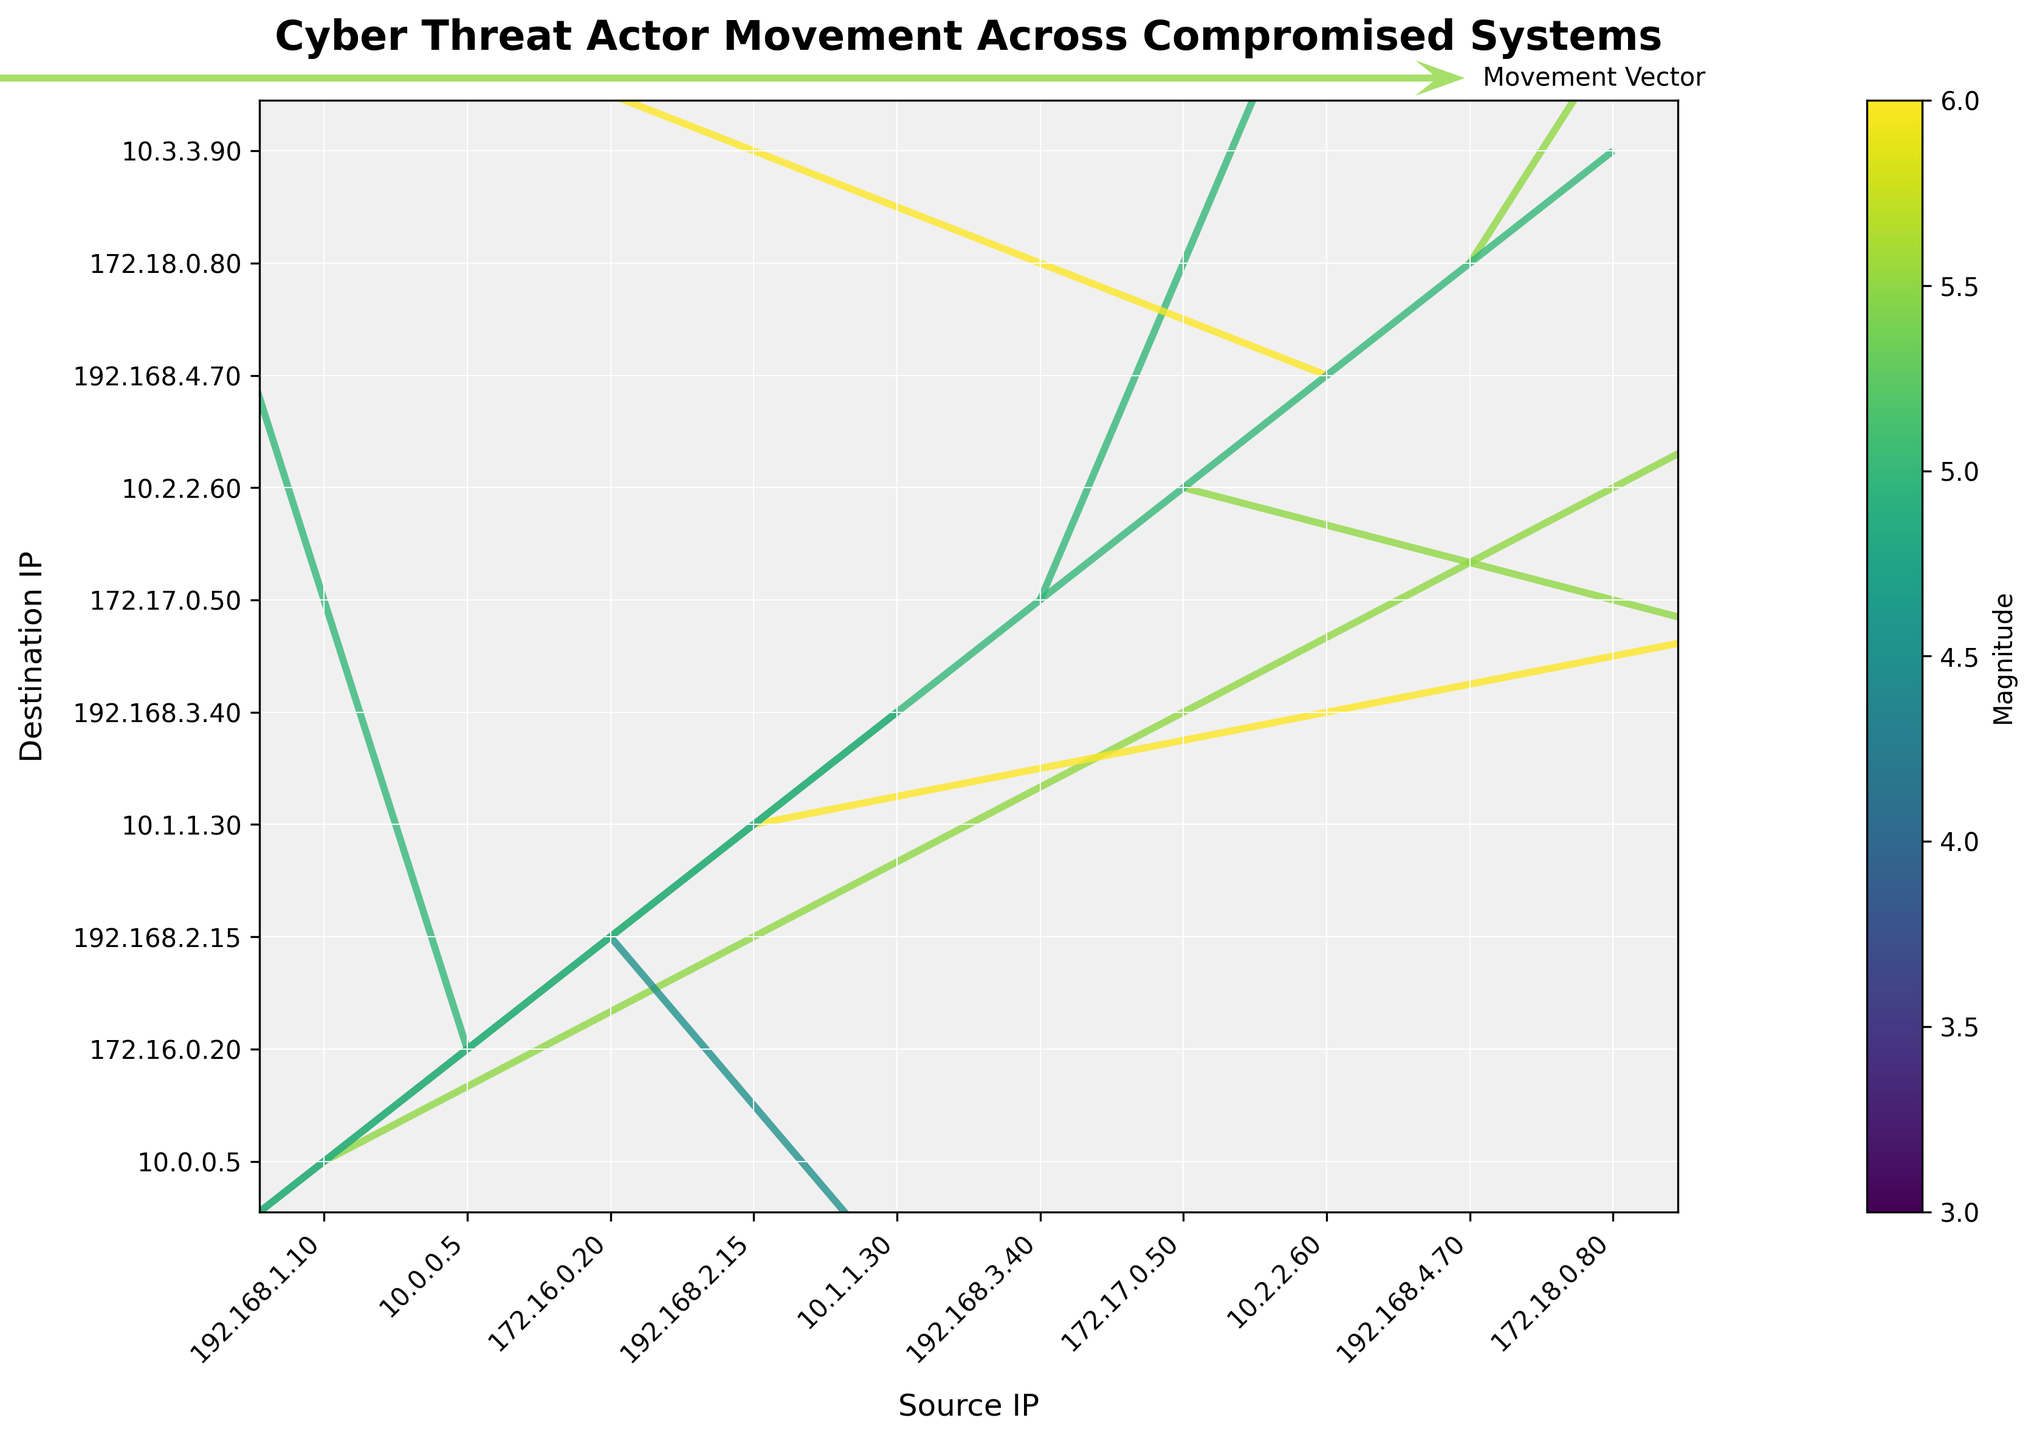What's the title of the plot? The title is located at the top center of the plot and is usually in a larger font and bolded to stand out. The title helps to provide a quick understanding of what the plot represents.
Answer: Cyber Threat Actor Movement Across Compromised Systems What colors are used to represent the magnitude of movement vectors in the plot? The colors can be seen in the quiver vectors themselves, with a gradient likely assigned according to magnitude using the color map shown in the color bar. These colors range from lighter to darker hues.
Answer: Various shades based on 'viridis' colormap Which axis label represents the 'Source IP'? The x-axis label is found along the bottom of the plot. The text "Source IP" is displayed here, indicating what dimension of data is being represented.
Answer: Source IP Which IP had the highest movement vector magnitude? By examining the color bar and the colors of the vectors, one can compare the magnitude values. The highest value is 6 according to the color scaling and vector color. This corresponds to the IPs 192.168.2.15 -> 10.1.1.30 and 10.2.2.60 -> 192.168.4.70.
Answer: 192.168.2.15 -> 10.1.1.30, 10.2.2.60 -> 192.168.4.70 Which vector shows movement in a negative x and positive y direction? By analyzing the vectors, the second vector (10.0.0.5 to 172.16.0.20) moves in a negative x direction and positive y direction.
Answer: 10.0.0.5 -> 172.16.0.20 What is the range of movement magnitudes displayed in the plot? By looking at the color bar, which represents the range of magnitudes, you can see the minimum and maximum values indicated.
Answer: 3 to 6 Which IP has the destination with the greatest positive y movement? By examining the y coordinates of the destination IPs while looking at the vector arrows' directions and magnitudes, the vector with the greatest positive y movement is 172.16.0.20 (moving from y = -3 to y = 1).
Answer: 172.17.0.50 How many vector movements represent a transition from a 192.168.x.x subnet? By counting the source IPs in the 192.168.x.x range from the list of data, there are four such IPs: 192.168.1.10, 192.168.2.15, 192.168.3.40, and 192.168.4.70.
Answer: Four Which vector shows movement in a completely negative direction in both x and y? By examining the vectors and their directions, the vector moving negatively in both x and y is from 10.1.1.30 to 192.168.3.40.
Answer: 10.1.1.30 -> 192.168.3.40 Between the '172.16.0.20 -> 192.168.2.15' and '192.168.2.15 -> 10.1.1.30', which one has a higher magnitude? By examining the plot's vectors and their corresponding colors with respect to the color bar, both vectors have different magnitudes as shown by the colors. The magnitude values for '172.16.0.20 -> 192.168.2.15' and '192.168.2.15 -> 10.1.1.30' are 3 and 6, respectively. Therefore, '192.168.2.15 -> 10.1.1.30' has a higher magnitude.
Answer: 192.168.2.15 -> 10.1.1.30 